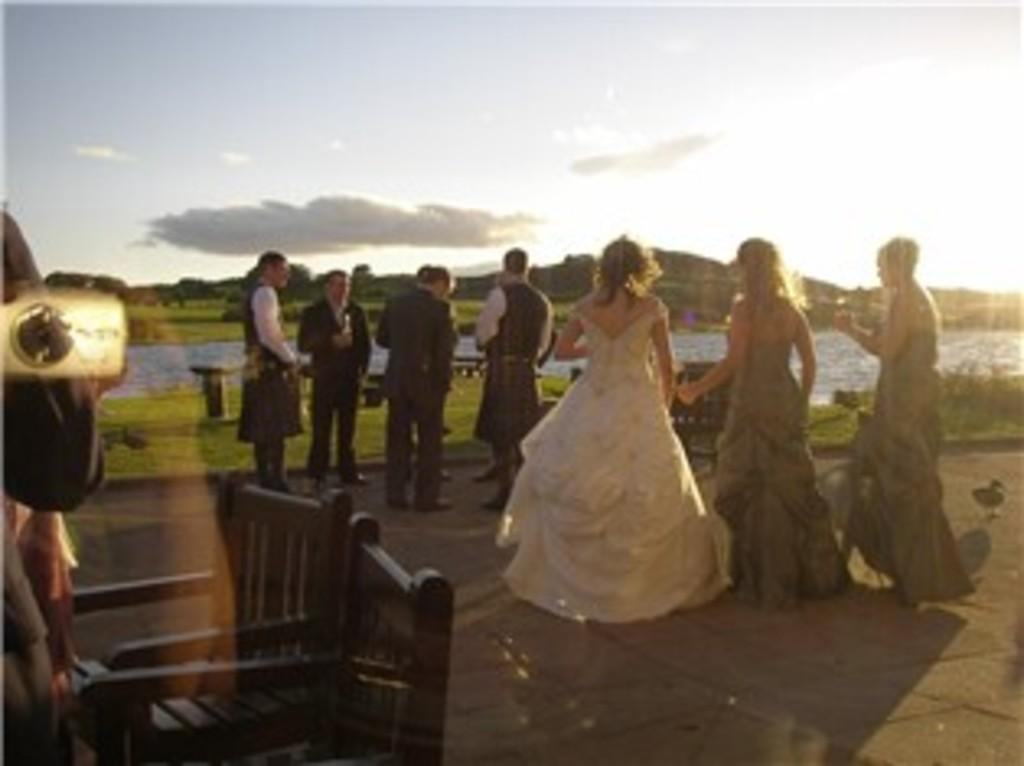What type of terrain is visible in the image? Ground, grass, and trees are visible in the image. Are there any people in the image? Yes, there are persons standing in the image. What natural features can be seen in the distance? Mountains are visible in the image. What is the condition of the water in the image? Water is visible in the image. What is visible in the background of the image? The sky is visible in the background of the image. What type of acoustics can be heard in the image? There is no sound or audio present in the image, so it is not possible to determine the acoustics. 